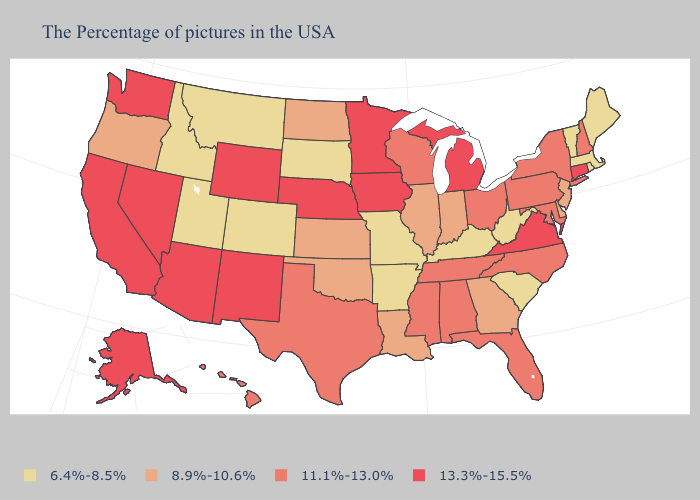What is the lowest value in the USA?
Give a very brief answer. 6.4%-8.5%. Does the map have missing data?
Give a very brief answer. No. Name the states that have a value in the range 13.3%-15.5%?
Give a very brief answer. Connecticut, Virginia, Michigan, Minnesota, Iowa, Nebraska, Wyoming, New Mexico, Arizona, Nevada, California, Washington, Alaska. What is the highest value in the West ?
Quick response, please. 13.3%-15.5%. Does Washington have the same value as New Mexico?
Write a very short answer. Yes. What is the value of Nebraska?
Give a very brief answer. 13.3%-15.5%. Name the states that have a value in the range 6.4%-8.5%?
Quick response, please. Maine, Massachusetts, Rhode Island, Vermont, South Carolina, West Virginia, Kentucky, Missouri, Arkansas, South Dakota, Colorado, Utah, Montana, Idaho. What is the lowest value in the USA?
Answer briefly. 6.4%-8.5%. Does Utah have the highest value in the USA?
Short answer required. No. What is the lowest value in the West?
Short answer required. 6.4%-8.5%. Name the states that have a value in the range 8.9%-10.6%?
Short answer required. New Jersey, Delaware, Georgia, Indiana, Illinois, Louisiana, Kansas, Oklahoma, North Dakota, Oregon. What is the value of Oregon?
Concise answer only. 8.9%-10.6%. What is the highest value in states that border South Carolina?
Give a very brief answer. 11.1%-13.0%. Does Idaho have the same value as Rhode Island?
Write a very short answer. Yes. 